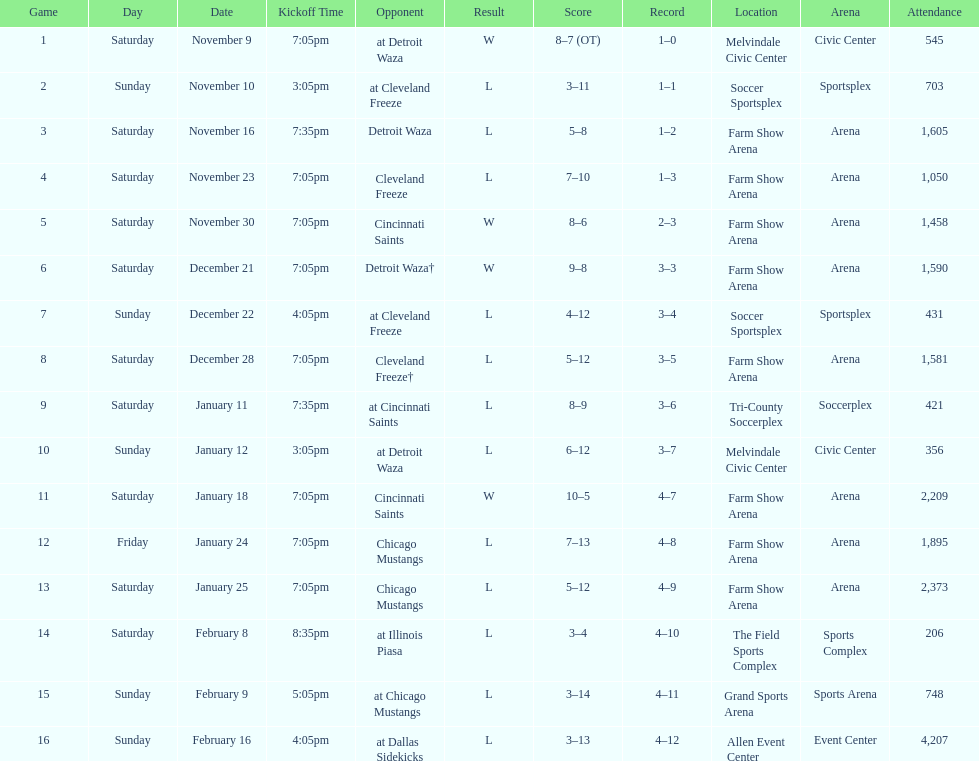Who was the first opponent on this list? Detroit Waza. 